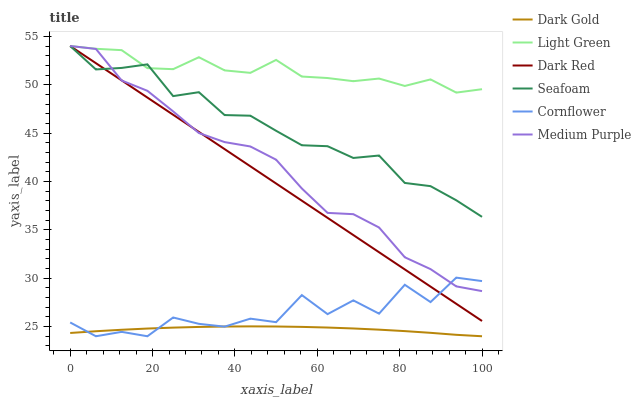Does Dark Red have the minimum area under the curve?
Answer yes or no. No. Does Dark Red have the maximum area under the curve?
Answer yes or no. No. Is Dark Gold the smoothest?
Answer yes or no. No. Is Dark Gold the roughest?
Answer yes or no. No. Does Dark Red have the lowest value?
Answer yes or no. No. Does Dark Gold have the highest value?
Answer yes or no. No. Is Dark Gold less than Seafoam?
Answer yes or no. Yes. Is Medium Purple greater than Dark Gold?
Answer yes or no. Yes. Does Dark Gold intersect Seafoam?
Answer yes or no. No. 